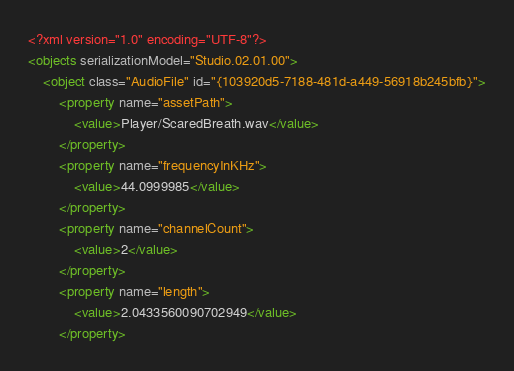<code> <loc_0><loc_0><loc_500><loc_500><_XML_><?xml version="1.0" encoding="UTF-8"?>
<objects serializationModel="Studio.02.01.00">
	<object class="AudioFile" id="{103920d5-7188-481d-a449-56918b245bfb}">
		<property name="assetPath">
			<value>Player/ScaredBreath.wav</value>
		</property>
		<property name="frequencyInKHz">
			<value>44.0999985</value>
		</property>
		<property name="channelCount">
			<value>2</value>
		</property>
		<property name="length">
			<value>2.0433560090702949</value>
		</property></code> 